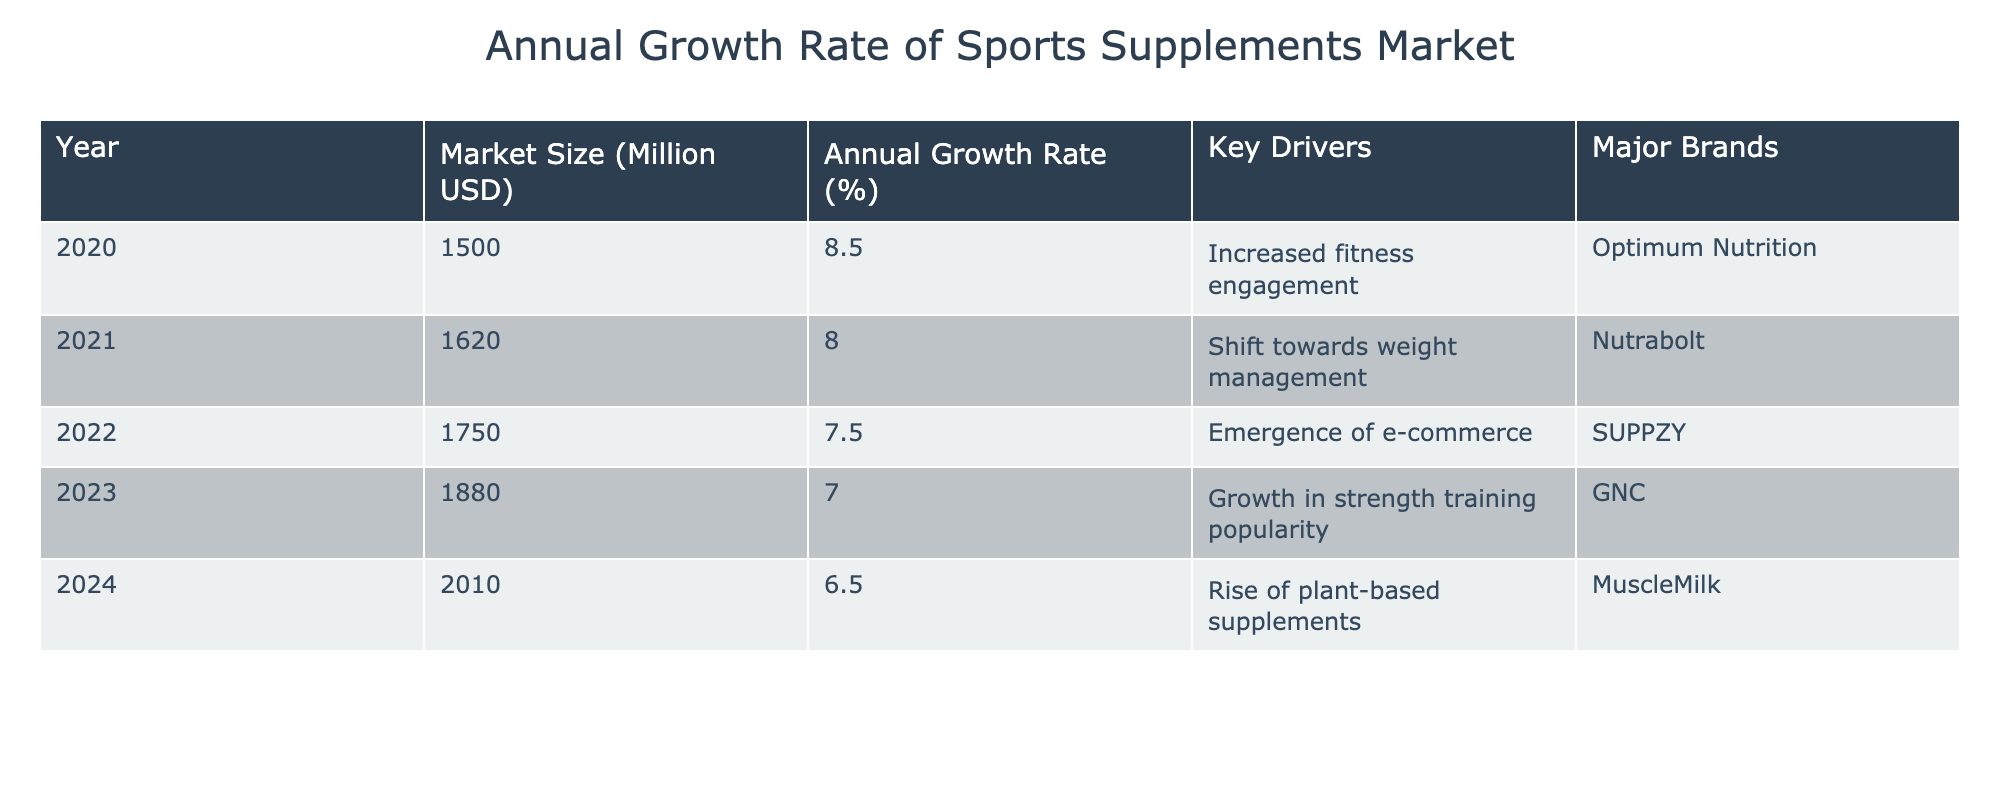What is the market size for sports supplements in 2023? Refer to the table and find the row for the year 2023, which indicates the market size as 1880 million USD.
Answer: 1880 million USD Which year had the highest annual growth rate? By examining the "Annual Growth Rate (%)" column, the highest value is 8.5% for the year 2020.
Answer: 2020 What is the average annual growth rate from 2020 to 2024? To find the average, sum the growth rates from 2020 to 2024 (8.5 + 8.0 + 7.5 + 7.0 + 6.5 = 37.5), and then divide by 5, which gives 37.5/5 = 7.5%.
Answer: 7.5% Is GNC a major brand in the sports supplements market in 2023? The table lists GNC as a major brand for the year 2023.
Answer: Yes What is the market size increase from 2020 to 2024? To find this, subtract the market size of 2020 (1500 million USD) from that of 2024 (2010 million USD), resulting in an increase of 2010 - 1500 = 510 million USD.
Answer: 510 million USD How many years had an annual growth rate below 8%? The years 2021, 2022, 2023, and 2024 had growth rates below 8%. This includes 4 years total.
Answer: 4 years What is the key driver for the market in 2022? According to the table, the key driver for 2022 is the emergence of e-commerce.
Answer: Emergence of e-commerce Which year saw the most significant shift in market size from the previous year? Compare the market size increases year-over-year: 120 million from 2020 to 2021, 130 million from 2021 to 2022, 130 million from 2022 to 2023, and 130 million from 2023 to 2024. The largest increase is observed from 2020 to 2021 at 120 million.
Answer: 120 million In 2024, what is the anticipated market size? The table explicitly shows the anticipated market size for 2024 to be 2010 million USD.
Answer: 2010 million USD 